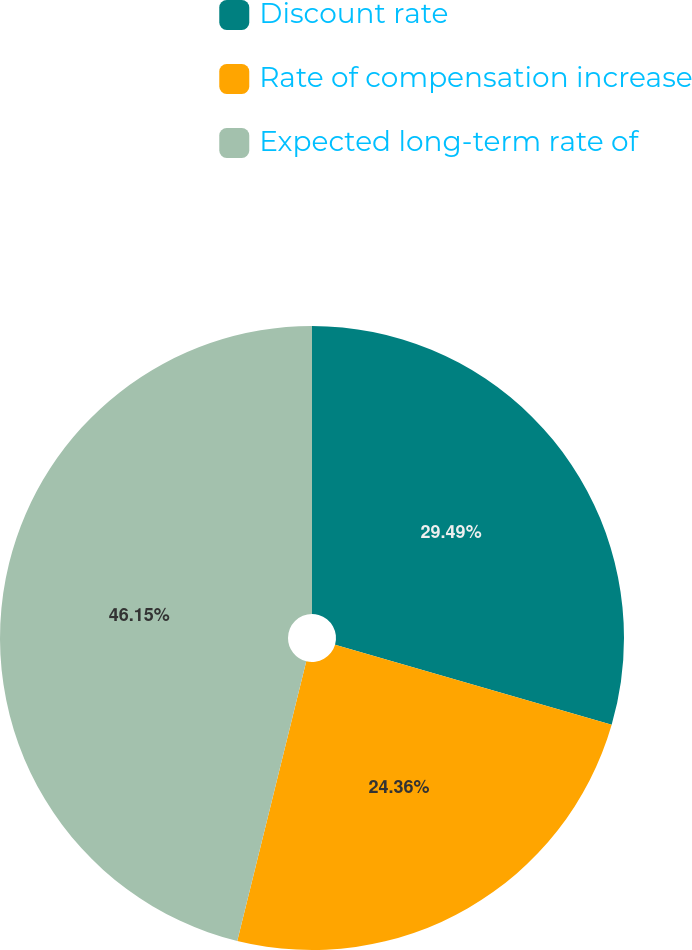Convert chart. <chart><loc_0><loc_0><loc_500><loc_500><pie_chart><fcel>Discount rate<fcel>Rate of compensation increase<fcel>Expected long-term rate of<nl><fcel>29.49%<fcel>24.36%<fcel>46.15%<nl></chart> 